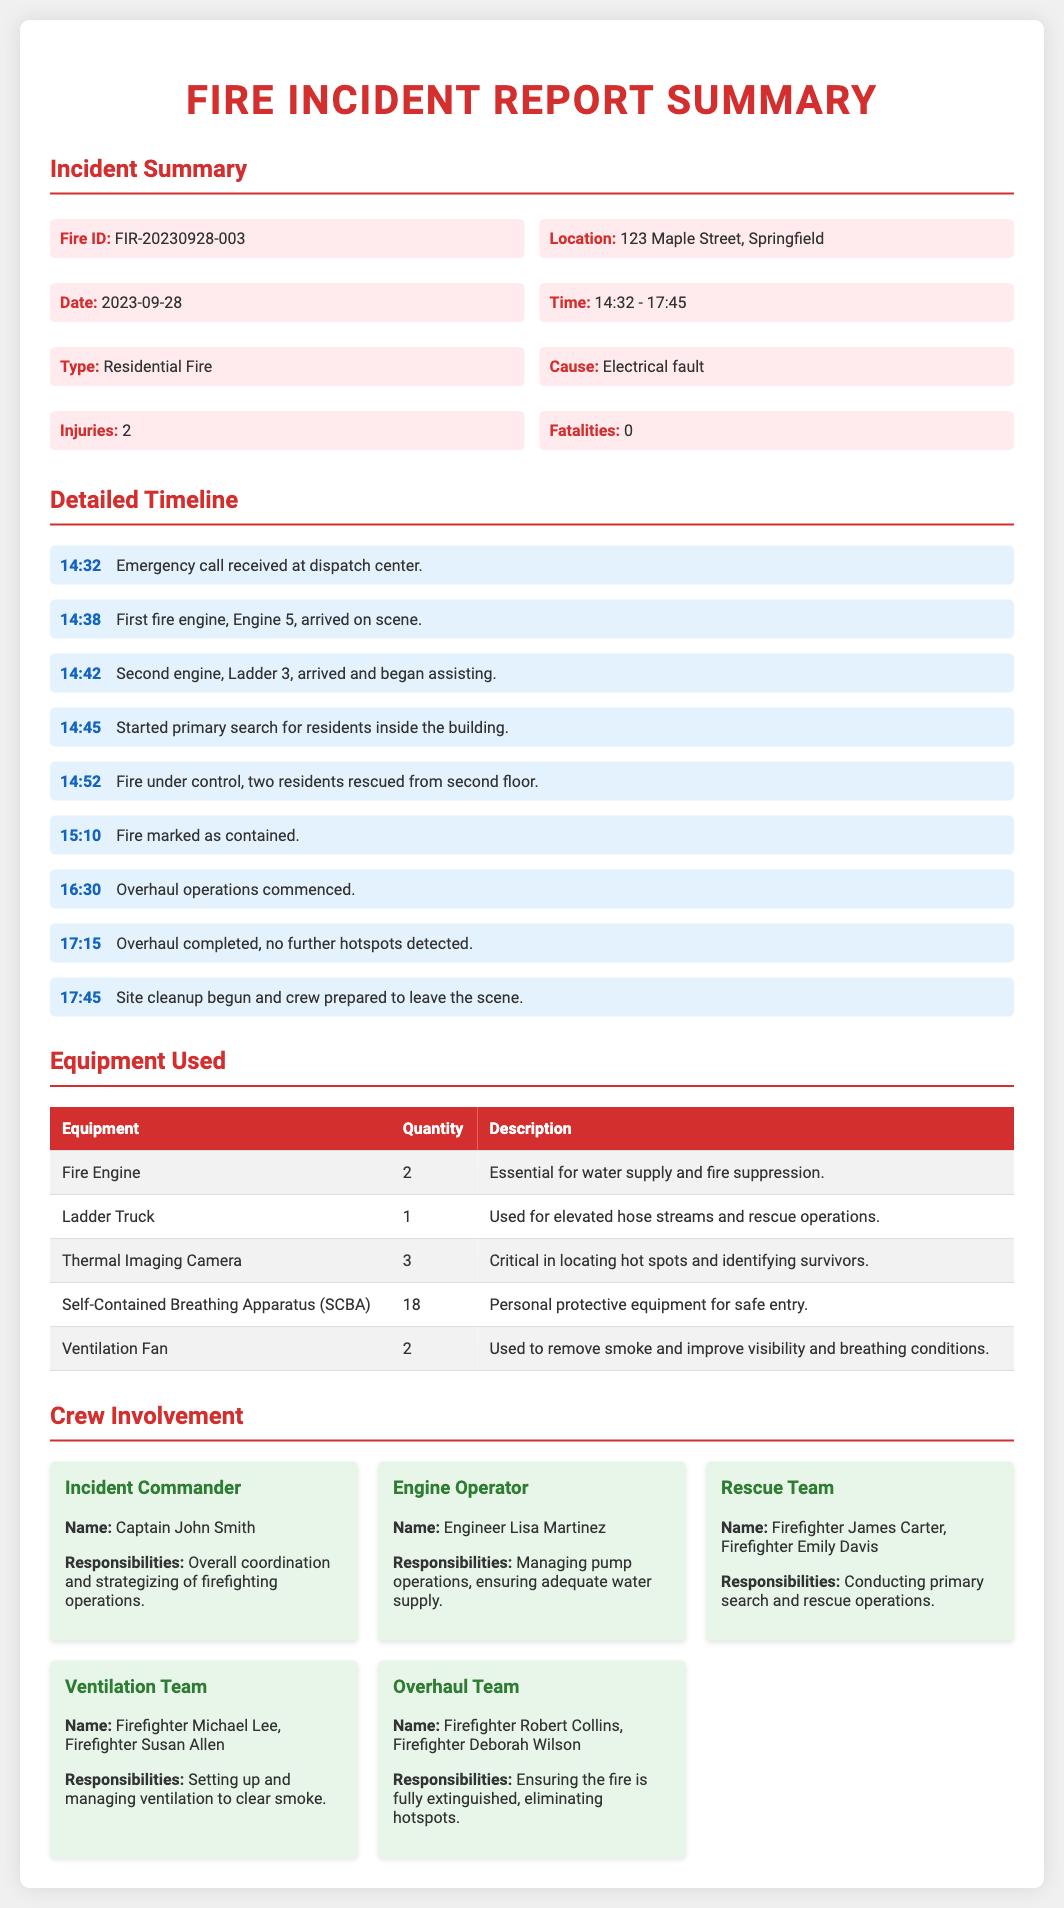What is the fire ID? The fire ID is specified in the incident summary section of the document.
Answer: FIR-20230928-003 What time did the first fire engine arrive? The arrival time of the first fire engine is noted in the detailed timeline section.
Answer: 14:38 How many people were injured? The number of injuries is stated in the incident summary section of the document.
Answer: 2 What was the cause of the fire? The cause of the fire is listed in the incident summary.
Answer: Electrical fault Who was the Incident Commander? The name of the Incident Commander can be found in the crew involvement section.
Answer: Captain John Smith How many fire engines were used? The quantity of fire engines is detailed in the equipment used section of the document.
Answer: 2 What was the last action taken at the scene? The final action during the incident is recorded in the detailed timeline.
Answer: Site cleanup begun How many thermal imaging cameras were deployed? The number of thermal imaging cameras is detailed in the equipment used section.
Answer: 3 Which crew members were part of the rescue team? The names of crew members in the rescue team are listed in the crew involvement section.
Answer: Firefighter James Carter, Firefighter Emily Davis 